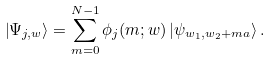Convert formula to latex. <formula><loc_0><loc_0><loc_500><loc_500>\left | \Psi _ { j , w } \right \rangle = \sum _ { m = 0 } ^ { N - 1 } \phi _ { j } ( m ; w ) \left | \psi _ { w _ { 1 } , w _ { 2 } + m a } \right \rangle .</formula> 